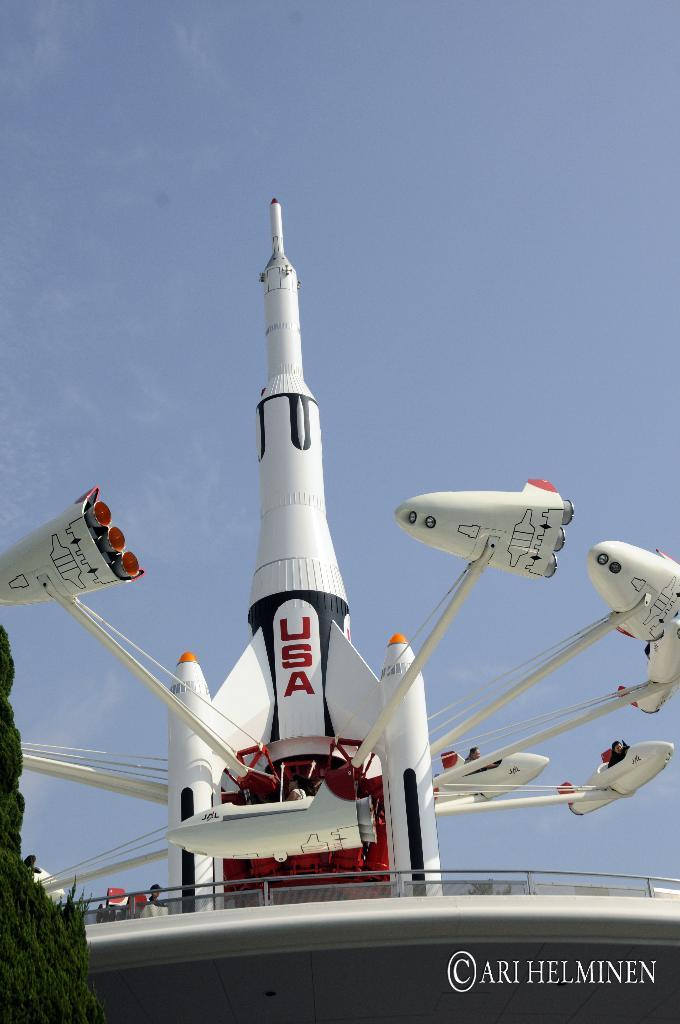What is the main subject of the image? The main subject of the image is a missile. What other objects or features can be seen in the image? There is a tree and the sky is visible in the image. Is there any text or logo present in the image? Yes, there is a watermark in the image. Where is the plate located in the image? There is no plate present in the image. Can you describe the sleeping habits of the tree in the image? Trees do not have sleeping habits, as they are inanimate objects. 